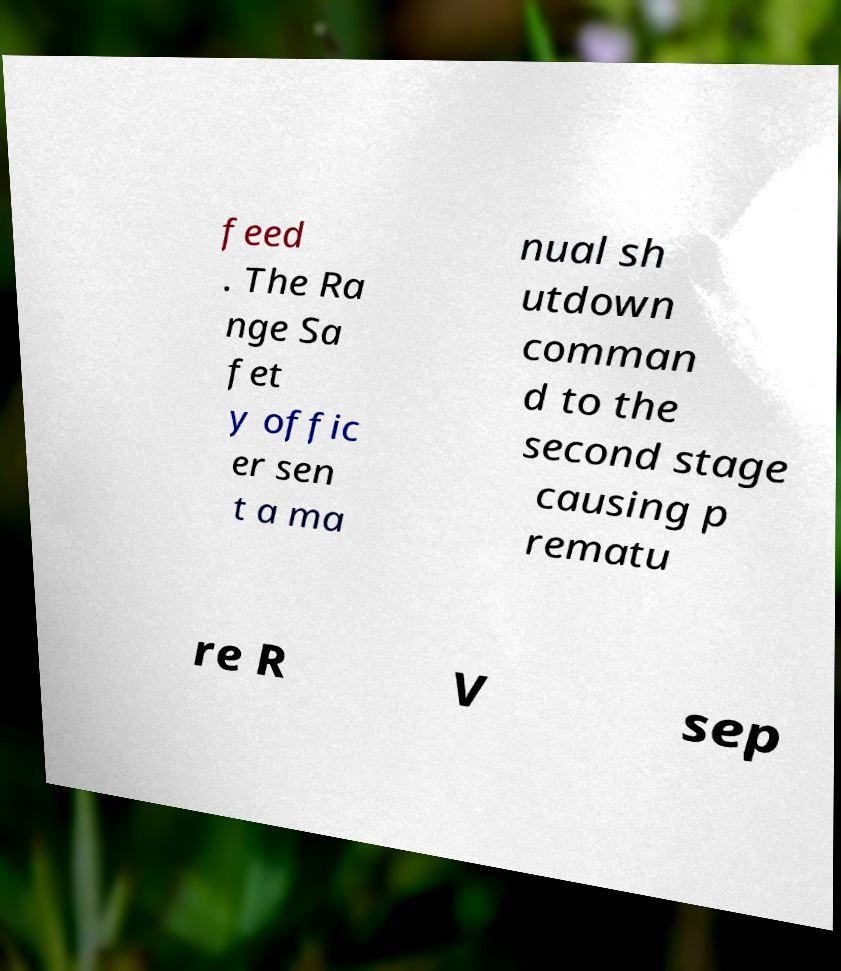For documentation purposes, I need the text within this image transcribed. Could you provide that? feed . The Ra nge Sa fet y offic er sen t a ma nual sh utdown comman d to the second stage causing p rematu re R V sep 